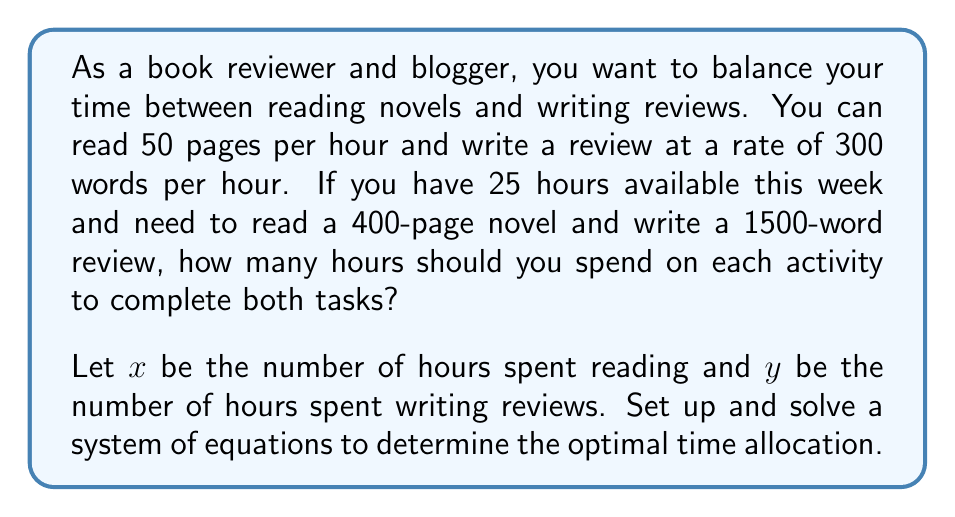Help me with this question. Let's approach this problem step-by-step:

1) First, let's set up our equations based on the given information:

   Equation 1 (Time constraint): $x + y = 25$
   Equation 2 (Reading): $50x = 400$
   Equation 3 (Writing): $300y = 1500$

2) Simplify Equation 2:
   $50x = 400$
   $x = 8$

3) Simplify Equation 3:
   $300y = 1500$
   $y = 5$

4) Now, let's check if these values satisfy Equation 1:
   $x + y = 8 + 5 = 13$

   This is less than the total available time of 25 hours, which means our solution is feasible.

5) To verify, let's calculate:
   Reading: 8 hours * 50 pages/hour = 400 pages
   Writing: 5 hours * 300 words/hour = 1500 words

   Both tasks are completed within the allotted time.

Therefore, the optimal time allocation is 8 hours for reading and 5 hours for writing reviews.
Answer: Reading time: 8 hours
Writing time: 5 hours 